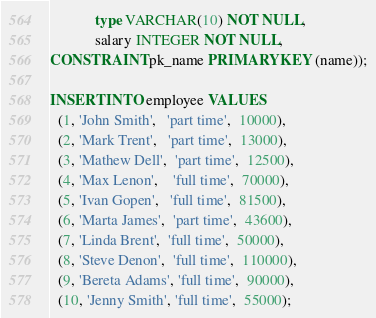<code> <loc_0><loc_0><loc_500><loc_500><_SQL_>			type VARCHAR(10) NOT NULL, 
			salary INTEGER NOT NULL, 
CONSTRAINT pk_name PRIMARY KEY (name));

INSERT INTO employee VALUES
  (1, 'John Smith',   'part time',  10000),
  (2, 'Mark Trent',   'part time',  13000),
  (3, 'Mathew Dell',  'part time',  12500),
  (4, 'Max Lenon',    'full time',  70000),
  (5, 'Ivan Gopen',   'full time',  81500),
  (6, 'Marta James',  'part time',  43600),
  (7, 'Linda Brent',  'full time',  50000),
  (8, 'Steve Denon',  'full time',  110000),
  (9, 'Bereta Adams', 'full time',  90000),
  (10, 'Jenny Smith', 'full time',  55000);
</code> 